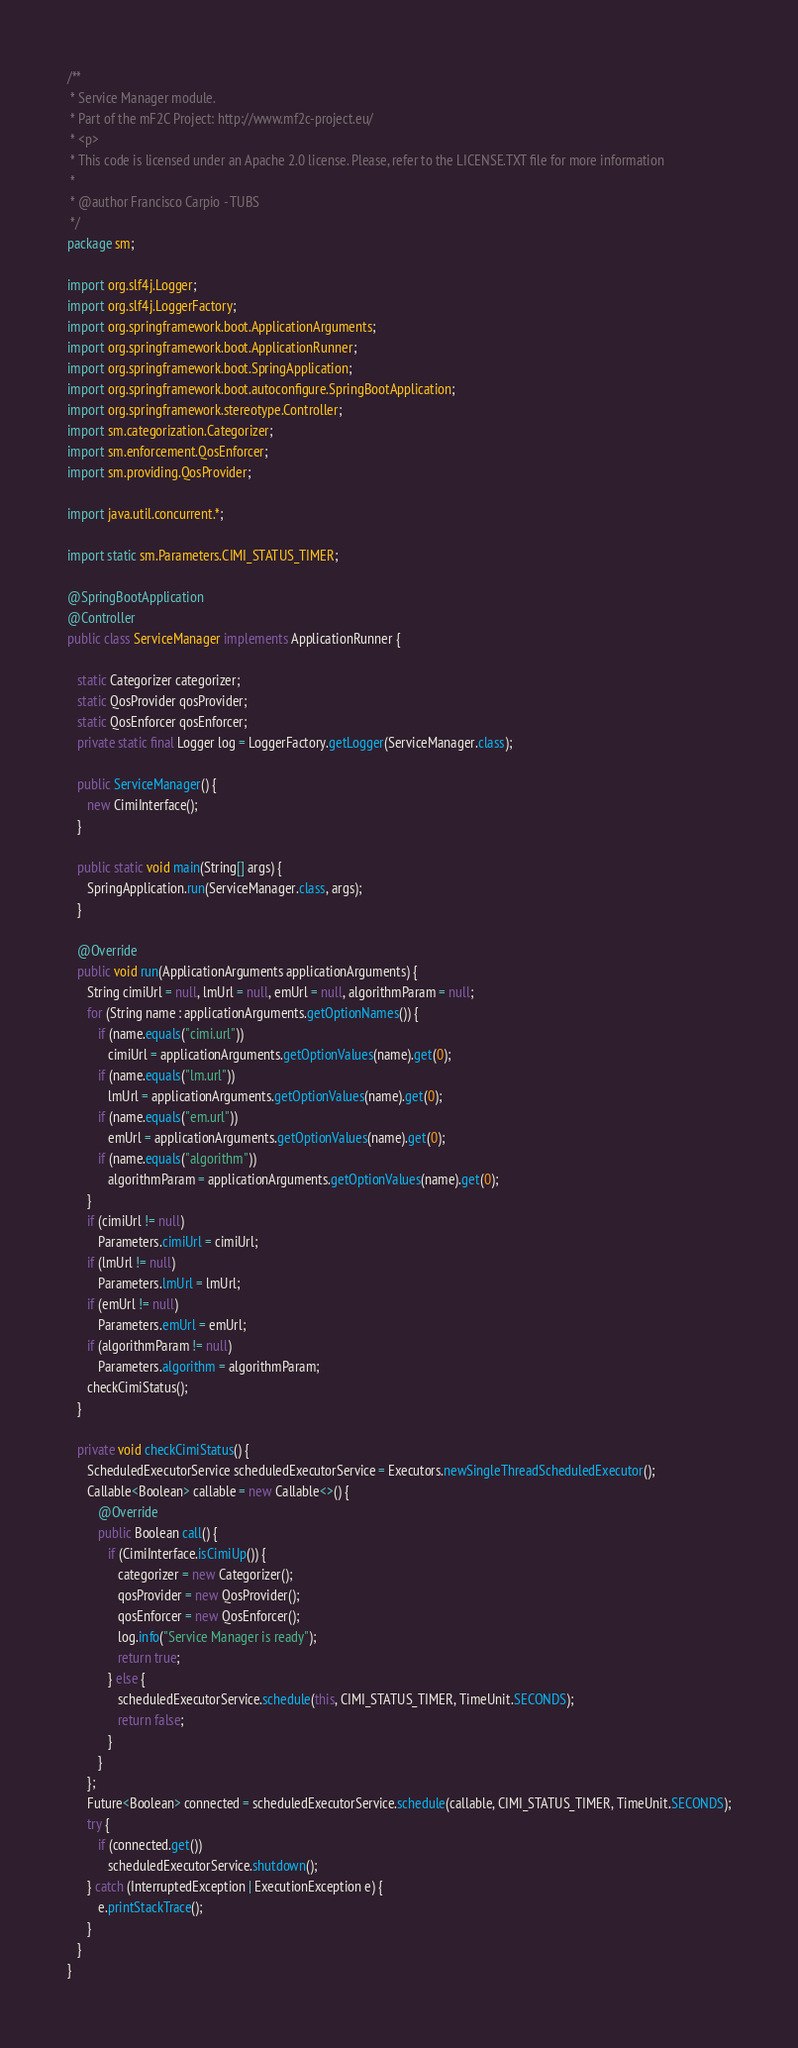Convert code to text. <code><loc_0><loc_0><loc_500><loc_500><_Java_>/**
 * Service Manager module.
 * Part of the mF2C Project: http://www.mf2c-project.eu/
 * <p>
 * This code is licensed under an Apache 2.0 license. Please, refer to the LICENSE.TXT file for more information
 *
 * @author Francisco Carpio - TUBS
 */
package sm;

import org.slf4j.Logger;
import org.slf4j.LoggerFactory;
import org.springframework.boot.ApplicationArguments;
import org.springframework.boot.ApplicationRunner;
import org.springframework.boot.SpringApplication;
import org.springframework.boot.autoconfigure.SpringBootApplication;
import org.springframework.stereotype.Controller;
import sm.categorization.Categorizer;
import sm.enforcement.QosEnforcer;
import sm.providing.QosProvider;

import java.util.concurrent.*;

import static sm.Parameters.CIMI_STATUS_TIMER;

@SpringBootApplication
@Controller
public class ServiceManager implements ApplicationRunner {

   static Categorizer categorizer;
   static QosProvider qosProvider;
   static QosEnforcer qosEnforcer;
   private static final Logger log = LoggerFactory.getLogger(ServiceManager.class);

   public ServiceManager() {
      new CimiInterface();
   }

   public static void main(String[] args) {
      SpringApplication.run(ServiceManager.class, args);
   }

   @Override
   public void run(ApplicationArguments applicationArguments) {
      String cimiUrl = null, lmUrl = null, emUrl = null, algorithmParam = null;
      for (String name : applicationArguments.getOptionNames()) {
         if (name.equals("cimi.url"))
            cimiUrl = applicationArguments.getOptionValues(name).get(0);
         if (name.equals("lm.url"))
            lmUrl = applicationArguments.getOptionValues(name).get(0);
         if (name.equals("em.url"))
            emUrl = applicationArguments.getOptionValues(name).get(0);
         if (name.equals("algorithm"))
            algorithmParam = applicationArguments.getOptionValues(name).get(0);
      }
      if (cimiUrl != null)
         Parameters.cimiUrl = cimiUrl;
      if (lmUrl != null)
         Parameters.lmUrl = lmUrl;
      if (emUrl != null)
         Parameters.emUrl = emUrl;
      if (algorithmParam != null)
         Parameters.algorithm = algorithmParam;
      checkCimiStatus();
   }

   private void checkCimiStatus() {
      ScheduledExecutorService scheduledExecutorService = Executors.newSingleThreadScheduledExecutor();
      Callable<Boolean> callable = new Callable<>() {
         @Override
         public Boolean call() {
            if (CimiInterface.isCimiUp()) {
               categorizer = new Categorizer();
               qosProvider = new QosProvider();
               qosEnforcer = new QosEnforcer();
               log.info("Service Manager is ready");
               return true;
            } else {
               scheduledExecutorService.schedule(this, CIMI_STATUS_TIMER, TimeUnit.SECONDS);
               return false;
            }
         }
      };
      Future<Boolean> connected = scheduledExecutorService.schedule(callable, CIMI_STATUS_TIMER, TimeUnit.SECONDS);
      try {
         if (connected.get())
            scheduledExecutorService.shutdown();
      } catch (InterruptedException | ExecutionException e) {
         e.printStackTrace();
      }
   }
}

</code> 